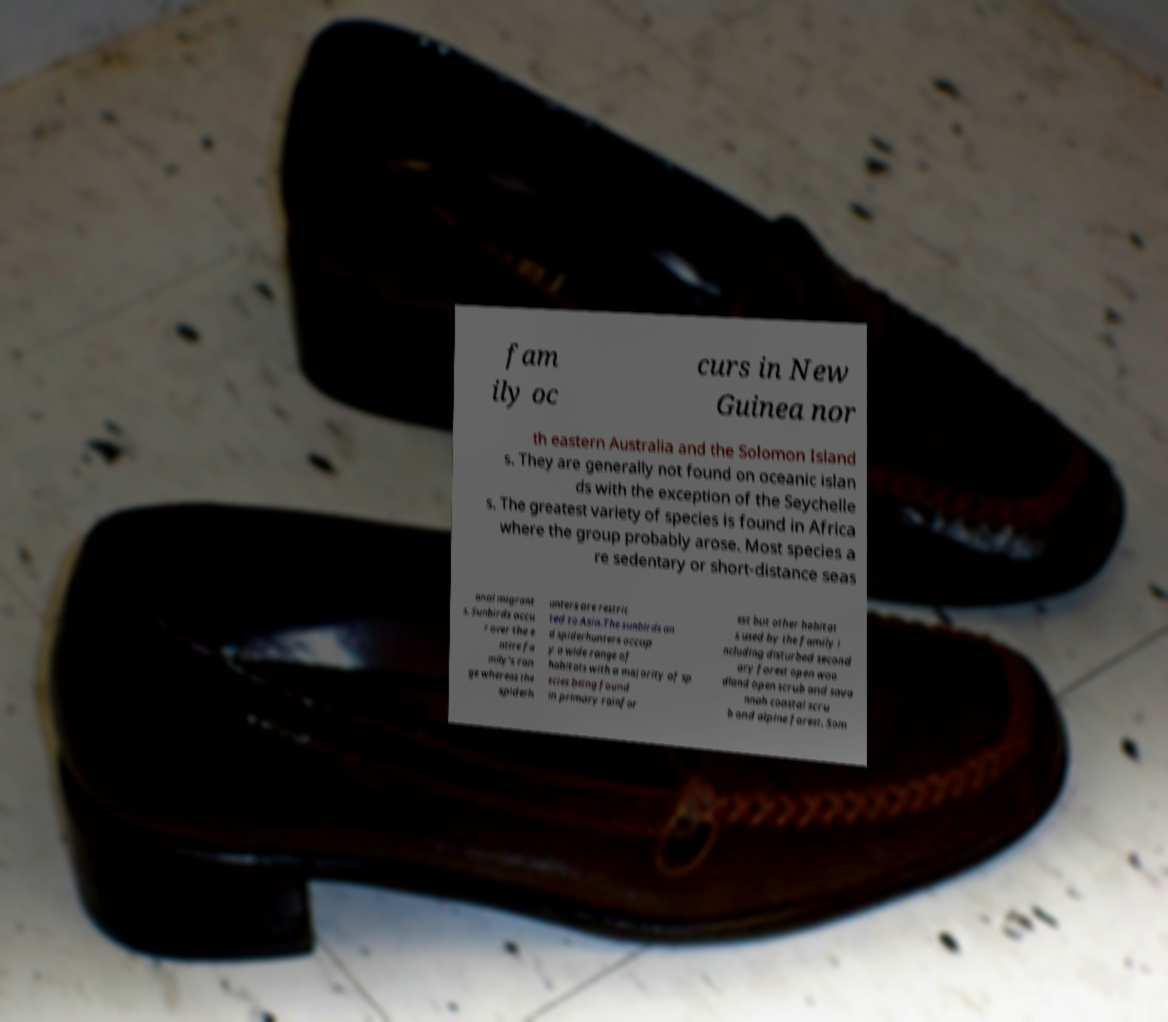Please read and relay the text visible in this image. What does it say? fam ily oc curs in New Guinea nor th eastern Australia and the Solomon Island s. They are generally not found on oceanic islan ds with the exception of the Seychelle s. The greatest variety of species is found in Africa where the group probably arose. Most species a re sedentary or short-distance seas onal migrant s. Sunbirds occu r over the e ntire fa mily's ran ge whereas the spiderh unters are restric ted to Asia.The sunbirds an d spiderhunters occup y a wide range of habitats with a majority of sp ecies being found in primary rainfor est but other habitat s used by the family i ncluding disturbed second ary forest open woo dland open scrub and sava nnah coastal scru b and alpine forest. Som 